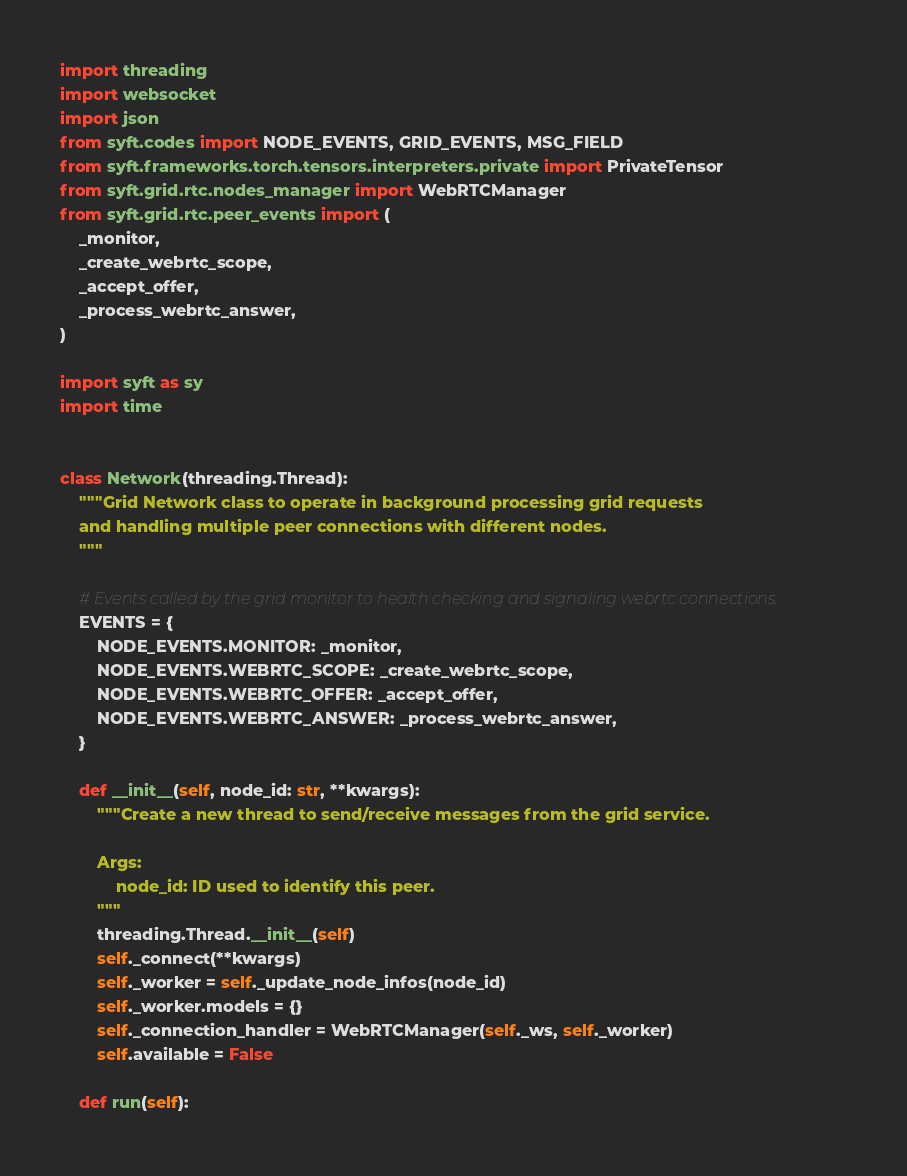<code> <loc_0><loc_0><loc_500><loc_500><_Python_>import threading
import websocket
import json
from syft.codes import NODE_EVENTS, GRID_EVENTS, MSG_FIELD
from syft.frameworks.torch.tensors.interpreters.private import PrivateTensor
from syft.grid.rtc.nodes_manager import WebRTCManager
from syft.grid.rtc.peer_events import (
    _monitor,
    _create_webrtc_scope,
    _accept_offer,
    _process_webrtc_answer,
)

import syft as sy
import time


class Network(threading.Thread):
    """Grid Network class to operate in background processing grid requests
    and handling multiple peer connections with different nodes.
    """

    # Events called by the grid monitor to health checking and signaling webrtc connections.
    EVENTS = {
        NODE_EVENTS.MONITOR: _monitor,
        NODE_EVENTS.WEBRTC_SCOPE: _create_webrtc_scope,
        NODE_EVENTS.WEBRTC_OFFER: _accept_offer,
        NODE_EVENTS.WEBRTC_ANSWER: _process_webrtc_answer,
    }

    def __init__(self, node_id: str, **kwargs):
        """Create a new thread to send/receive messages from the grid service.

        Args:
            node_id: ID used to identify this peer.
        """
        threading.Thread.__init__(self)
        self._connect(**kwargs)
        self._worker = self._update_node_infos(node_id)
        self._worker.models = {}
        self._connection_handler = WebRTCManager(self._ws, self._worker)
        self.available = False

    def run(self):</code> 